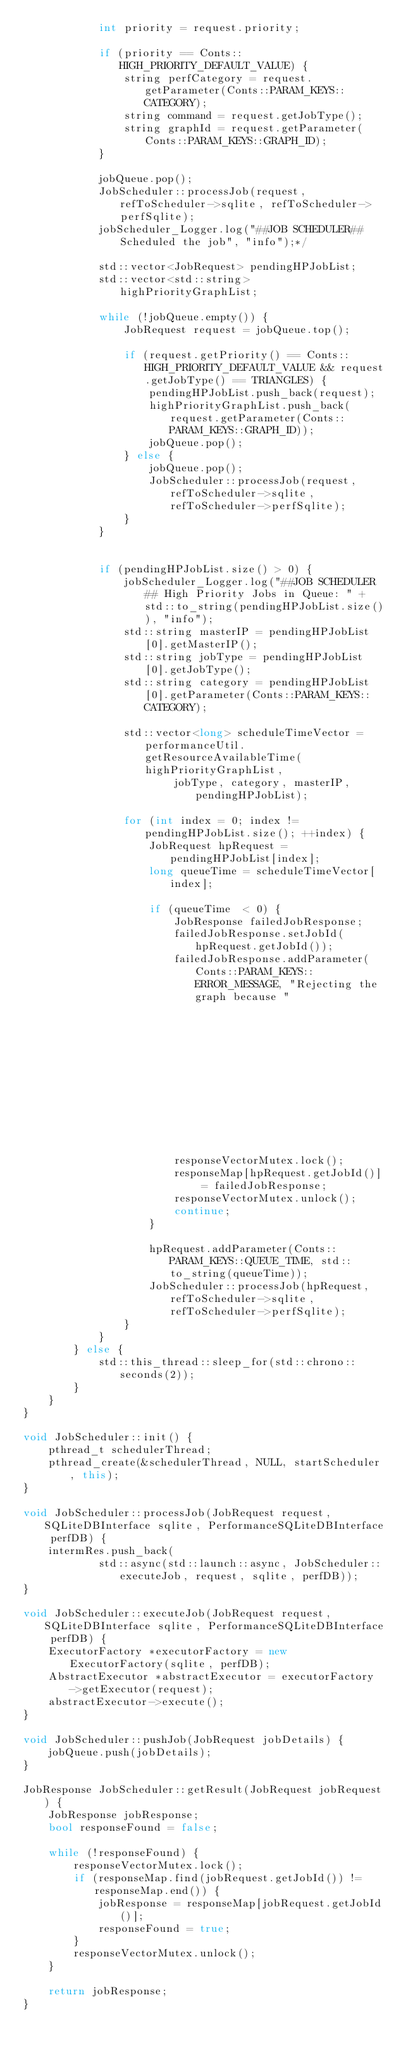<code> <loc_0><loc_0><loc_500><loc_500><_C++_>            int priority = request.priority;

            if (priority == Conts::HIGH_PRIORITY_DEFAULT_VALUE) {
                string perfCategory = request.getParameter(Conts::PARAM_KEYS::CATEGORY);
                string command = request.getJobType();
                string graphId = request.getParameter(Conts::PARAM_KEYS::GRAPH_ID);
            }

            jobQueue.pop();
            JobScheduler::processJob(request, refToScheduler->sqlite, refToScheduler->perfSqlite);
            jobScheduler_Logger.log("##JOB SCHEDULER## Scheduled the job", "info");*/

            std::vector<JobRequest> pendingHPJobList;
            std::vector<std::string> highPriorityGraphList;

            while (!jobQueue.empty()) {
                JobRequest request = jobQueue.top();

                if (request.getPriority() == Conts::HIGH_PRIORITY_DEFAULT_VALUE && request.getJobType() == TRIANGLES) {
                    pendingHPJobList.push_back(request);
                    highPriorityGraphList.push_back(request.getParameter(Conts::PARAM_KEYS::GRAPH_ID));
                    jobQueue.pop();
                } else {
                    jobQueue.pop();
                    JobScheduler::processJob(request, refToScheduler->sqlite, refToScheduler->perfSqlite);
                }
            }


            if (pendingHPJobList.size() > 0) {
                jobScheduler_Logger.log("##JOB SCHEDULER## High Priority Jobs in Queue: " + std::to_string(pendingHPJobList.size()), "info");
                std::string masterIP = pendingHPJobList[0].getMasterIP();
                std::string jobType = pendingHPJobList[0].getJobType();
                std::string category = pendingHPJobList[0].getParameter(Conts::PARAM_KEYS::CATEGORY);

                std::vector<long> scheduleTimeVector = performanceUtil.getResourceAvailableTime(highPriorityGraphList,
                        jobType, category, masterIP, pendingHPJobList);

                for (int index = 0; index != pendingHPJobList.size(); ++index) {
                    JobRequest hpRequest = pendingHPJobList[index];
                    long queueTime = scheduleTimeVector[index];

                    if (queueTime  < 0) {
                        JobResponse failedJobResponse;
                        failedJobResponse.setJobId(hpRequest.getJobId());
                        failedJobResponse.addParameter(Conts::PARAM_KEYS::ERROR_MESSAGE, "Rejecting the graph because "
                                                                                         "SLA cannot be maintained");
                        responseVectorMutex.lock();
                        responseMap[hpRequest.getJobId()] = failedJobResponse;
                        responseVectorMutex.unlock();
                        continue;
                    }

                    hpRequest.addParameter(Conts::PARAM_KEYS::QUEUE_TIME, std::to_string(queueTime));
                    JobScheduler::processJob(hpRequest, refToScheduler->sqlite, refToScheduler->perfSqlite);
                }
            }
        } else {
            std::this_thread::sleep_for(std::chrono::seconds(2));
        }
    }
}

void JobScheduler::init() {
    pthread_t schedulerThread;
    pthread_create(&schedulerThread, NULL, startScheduler, this);
}

void JobScheduler::processJob(JobRequest request, SQLiteDBInterface sqlite, PerformanceSQLiteDBInterface perfDB) {
    intermRes.push_back(
            std::async(std::launch::async, JobScheduler::executeJob, request, sqlite, perfDB));
}

void JobScheduler::executeJob(JobRequest request, SQLiteDBInterface sqlite, PerformanceSQLiteDBInterface perfDB) {
    ExecutorFactory *executorFactory = new ExecutorFactory(sqlite, perfDB);
    AbstractExecutor *abstractExecutor = executorFactory->getExecutor(request);
    abstractExecutor->execute();
}

void JobScheduler::pushJob(JobRequest jobDetails) {
    jobQueue.push(jobDetails);
}

JobResponse JobScheduler::getResult(JobRequest jobRequest) {
    JobResponse jobResponse;
    bool responseFound = false;

    while (!responseFound) {
        responseVectorMutex.lock();
        if (responseMap.find(jobRequest.getJobId()) != responseMap.end()) {
            jobResponse = responseMap[jobRequest.getJobId()];
            responseFound = true;
        }
        responseVectorMutex.unlock();
    }

    return jobResponse;
}</code> 